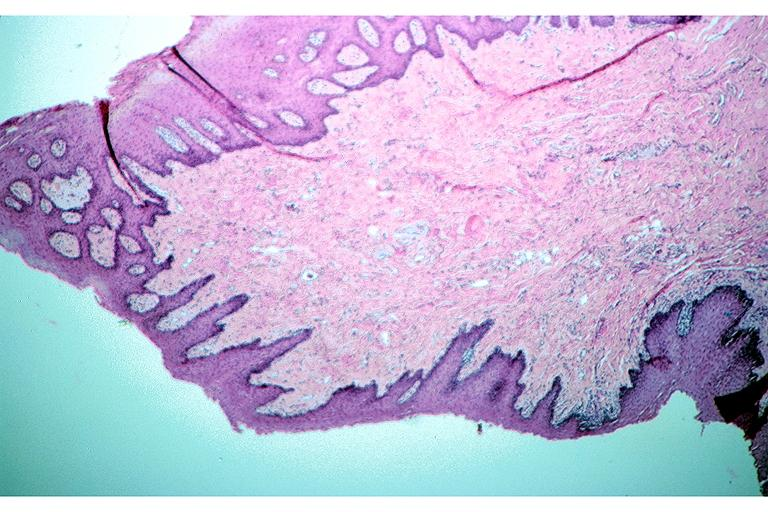does primary show irritation fibroma?
Answer the question using a single word or phrase. No 